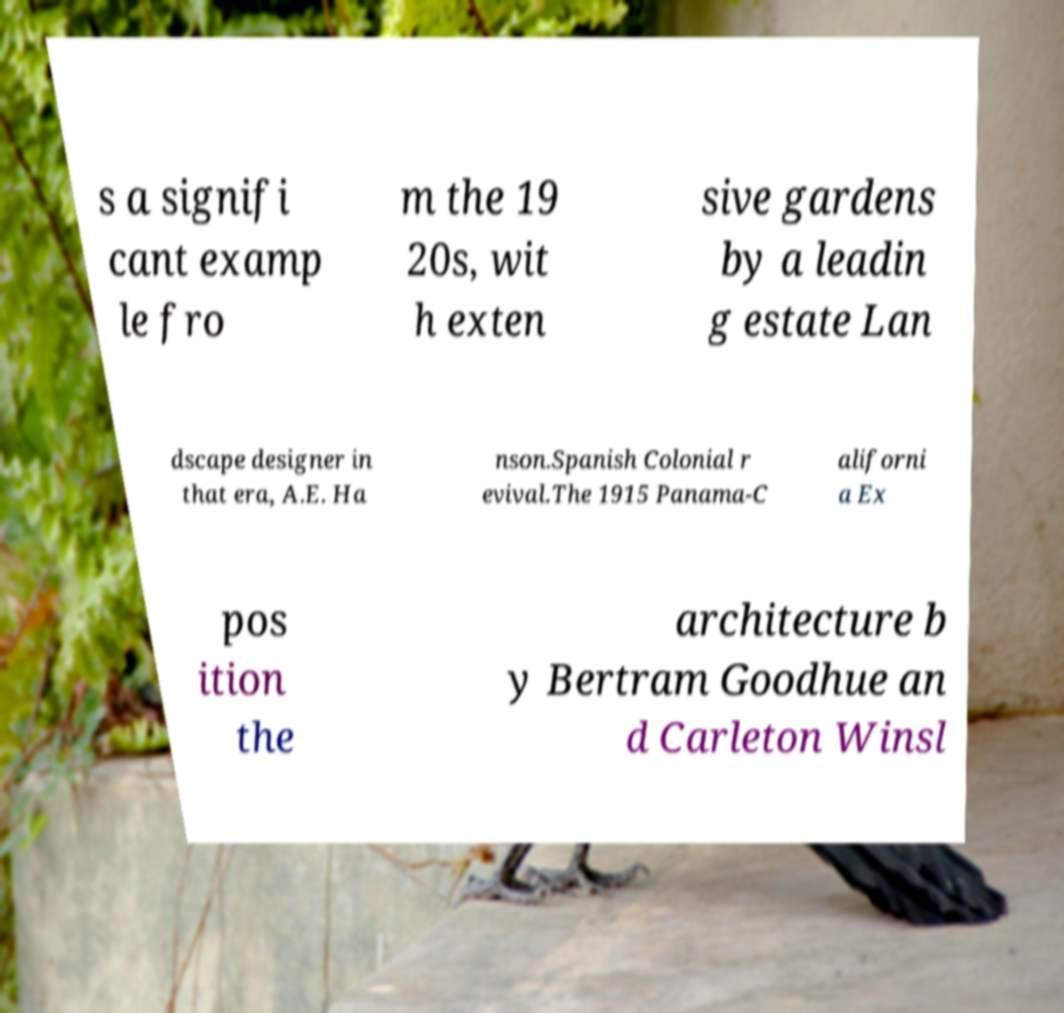For documentation purposes, I need the text within this image transcribed. Could you provide that? s a signifi cant examp le fro m the 19 20s, wit h exten sive gardens by a leadin g estate Lan dscape designer in that era, A.E. Ha nson.Spanish Colonial r evival.The 1915 Panama-C aliforni a Ex pos ition the architecture b y Bertram Goodhue an d Carleton Winsl 